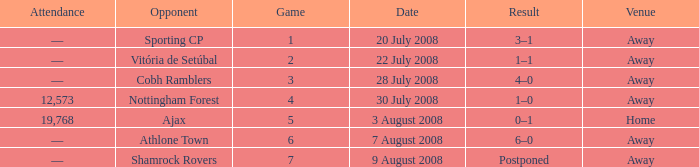What is the result of the game with a game number greater than 6 and an away venue? Postponed. 